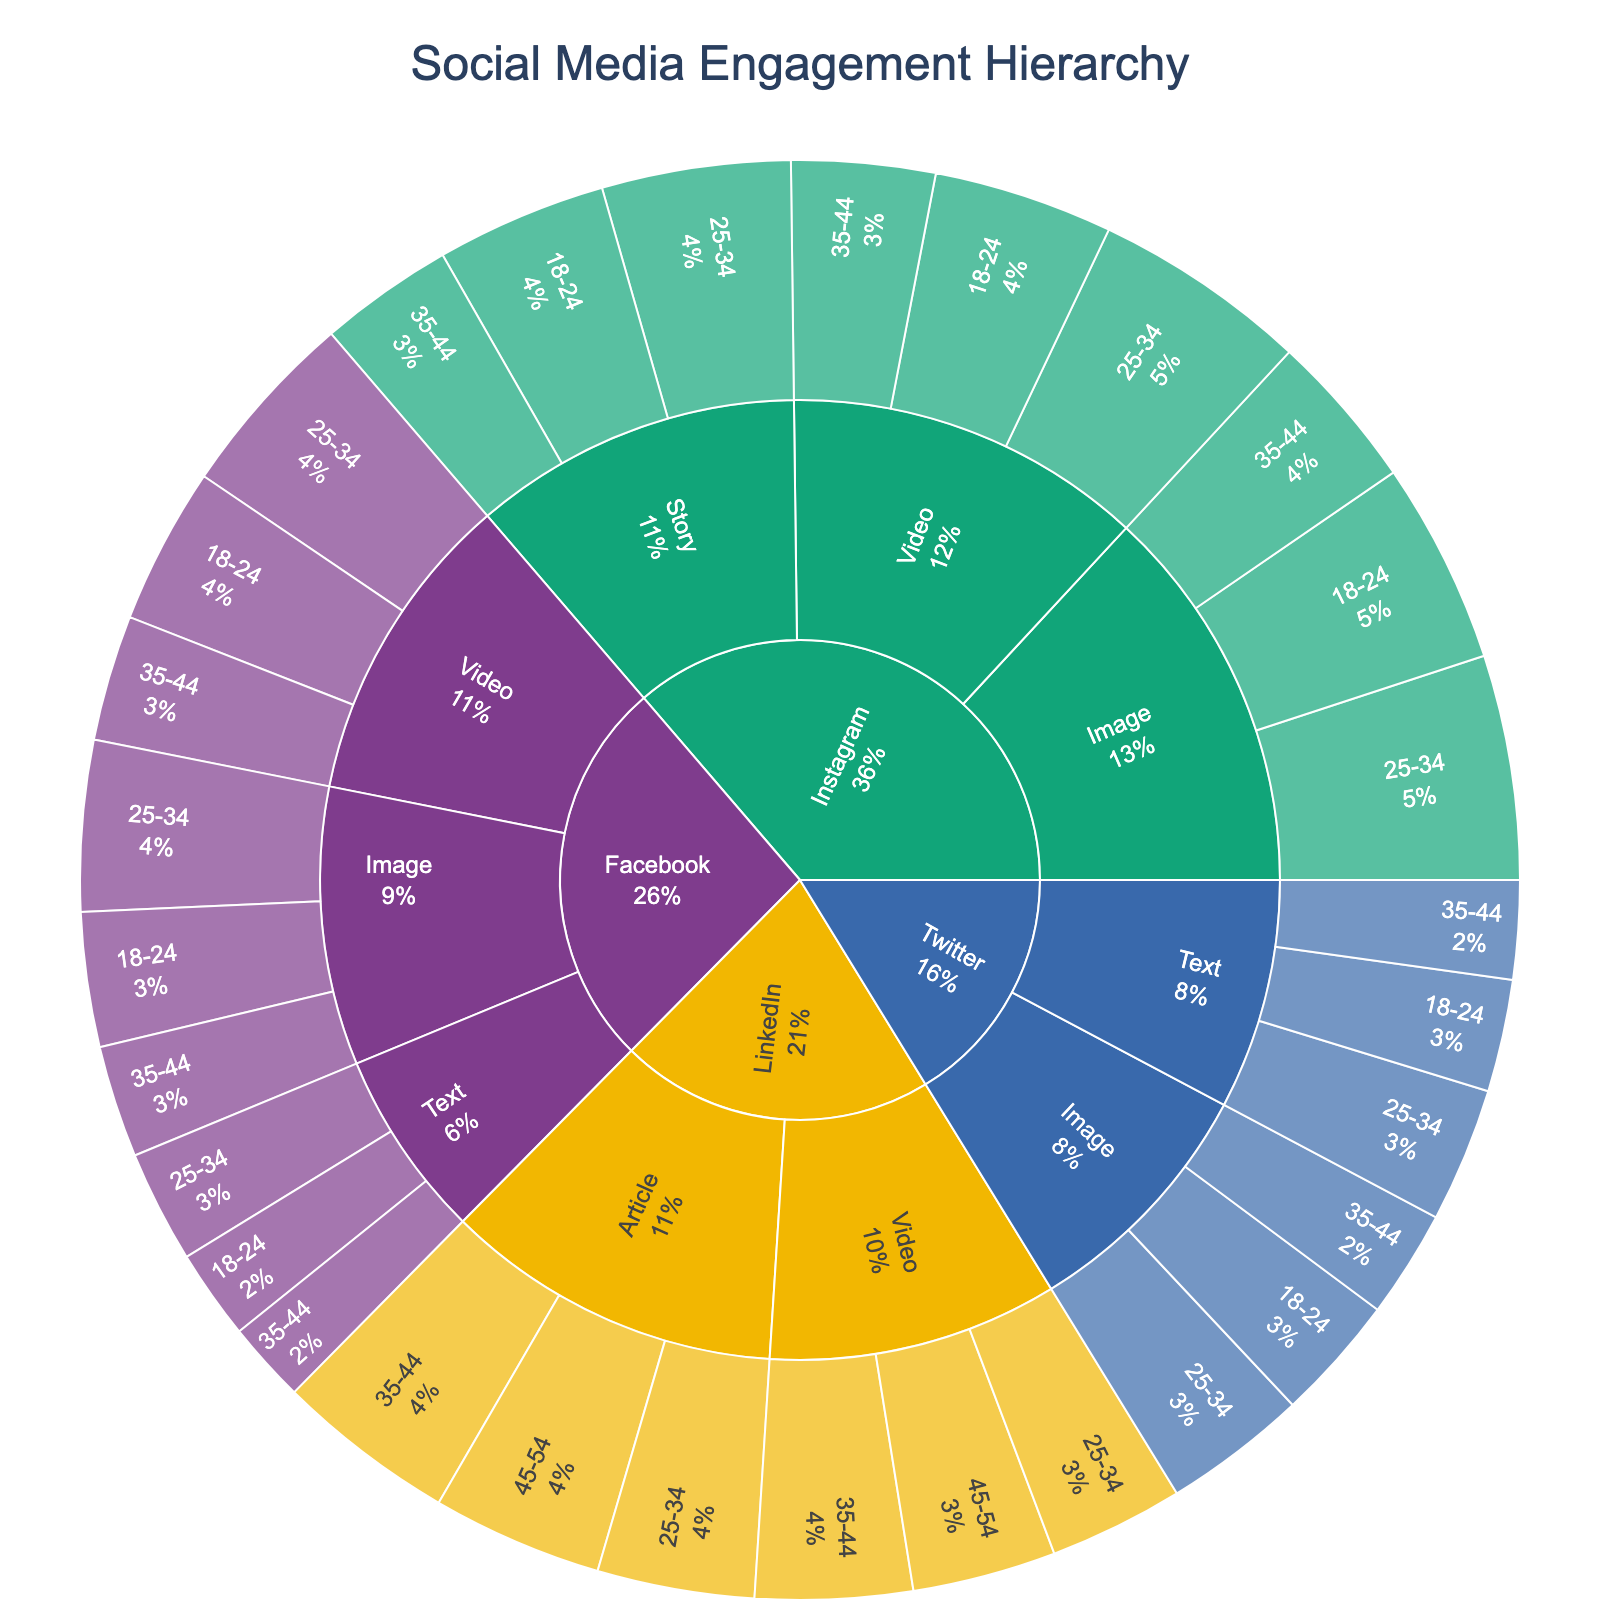What platforms are included in the plot? Identify the different segments representing each platform in the outermost ring. You will see segments labeled as Facebook, Instagram, Twitter, and LinkedIn.
Answer: Facebook, Instagram, Twitter, LinkedIn Which platform has the highest engagement value for video content among the 18-24 demographic? Locate the segments for each platform that are specifically for "Video" content and then find the 18-24 demographic within those segments. The highest engagement value is found within Instagram's segment for video content.
Answer: Instagram Among all audience demographics, which content type on Facebook shows the highest engagement value? Focus on the Facebook segment and then drill down into each content type to compare the engagement values for each audience demographic. Video content for the 25-34 demographic has the highest engagement.
Answer: Video What is the total engagement value for Instagram across all content types and demographics? Sum the engagement values for all content types and demographics under Instagram: (45+50+35) for Image + (40+48+32) for Video + (38+42+30) for Story. This yields 278.
Answer: 278 Which audience demographic has the highest engagement value for LinkedIn? Drill down into the LinkedIn segment and identify the engagement values for each audience demographic. The 35-44 segment has the highest value when combined across content types.
Answer: 35-44 How does the engagement for text content on Twitter for 18-24 compare to 25-34 demographic? Look into the Twitter segment, then to Text content, and compare the values for the 18-24 demographic to the 25-34 demographic. The engagement value for 25-34 (30) is higher than for 18-24 (25).
Answer: The 25-34 demographic has higher engagement Which content type has the most equal distribution of engagement across different age groups on Facebook? Check each content type under Facebook and compare the engagement values across age groups. Image content (30, 38, 25) shows the most similar engagement values.
Answer: Image What's the difference in engagement value between the highest and lowest engaging content types on LinkedIn for the 35-44 demographic? For LinkedIn, compare the engagement values for the 35-44 demographic across all content types: Article (40) and Video (35). The difference is 5.
Answer: 5 What content type and platform combination has the lowest engagement value for the 35-44 demographic? Identify the lowest engagement values across all platforms and content types for the 35-44 demographic. The lowest value is Text content on Facebook, which has 18.
Answer: Facebook Text What's the combined engagement value for image content across all demographics on Twitter? Sum the engagement values for Image content across all demographics on Twitter: 28 (18-24) + 32 (25-34) + 24 (35-44). This results in a total of 84.
Answer: 84 